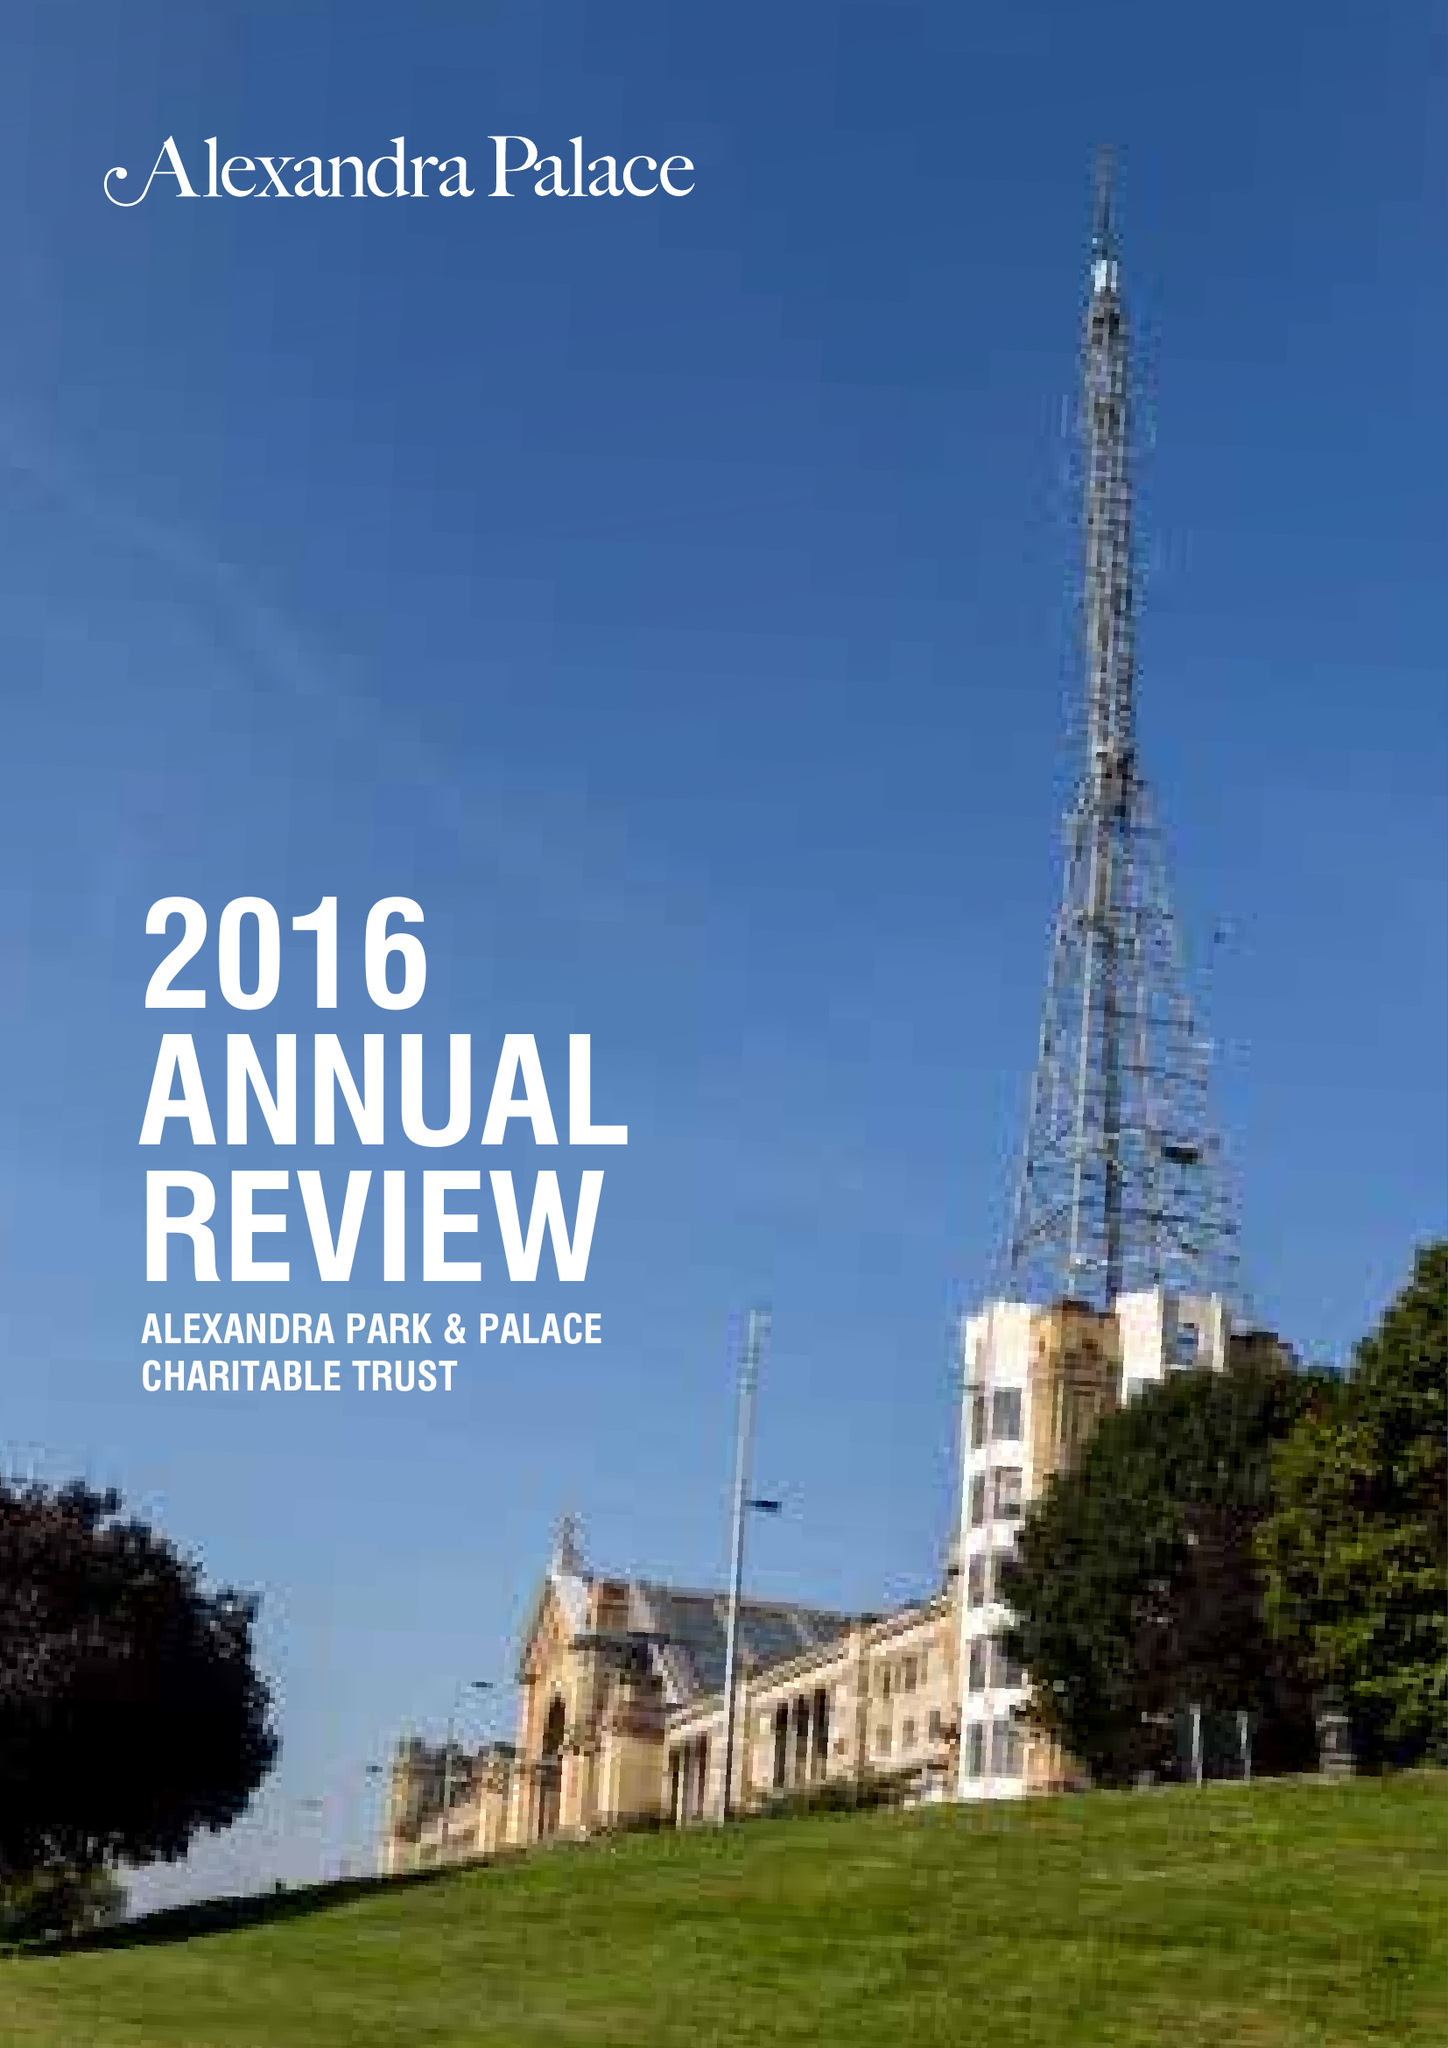What is the value for the income_annually_in_british_pounds?
Answer the question using a single word or phrase. 40935000.00 